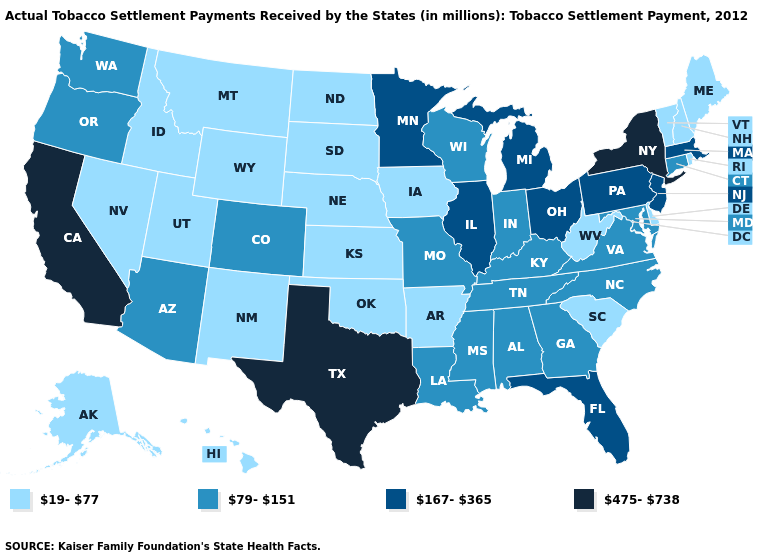What is the value of Tennessee?
Be succinct. 79-151. What is the value of New Mexico?
Keep it brief. 19-77. What is the value of Wyoming?
Short answer required. 19-77. What is the highest value in states that border Texas?
Be succinct. 79-151. Does Washington have a lower value than Oregon?
Answer briefly. No. Does Delaware have the highest value in the South?
Short answer required. No. Name the states that have a value in the range 19-77?
Answer briefly. Alaska, Arkansas, Delaware, Hawaii, Idaho, Iowa, Kansas, Maine, Montana, Nebraska, Nevada, New Hampshire, New Mexico, North Dakota, Oklahoma, Rhode Island, South Carolina, South Dakota, Utah, Vermont, West Virginia, Wyoming. Which states have the highest value in the USA?
Answer briefly. California, New York, Texas. Name the states that have a value in the range 167-365?
Give a very brief answer. Florida, Illinois, Massachusetts, Michigan, Minnesota, New Jersey, Ohio, Pennsylvania. Does Arkansas have the same value as Washington?
Quick response, please. No. Does Vermont have the lowest value in the USA?
Concise answer only. Yes. Among the states that border Indiana , which have the highest value?
Quick response, please. Illinois, Michigan, Ohio. Does Mississippi have a higher value than Indiana?
Be succinct. No. Among the states that border Michigan , which have the highest value?
Short answer required. Ohio. How many symbols are there in the legend?
Short answer required. 4. 